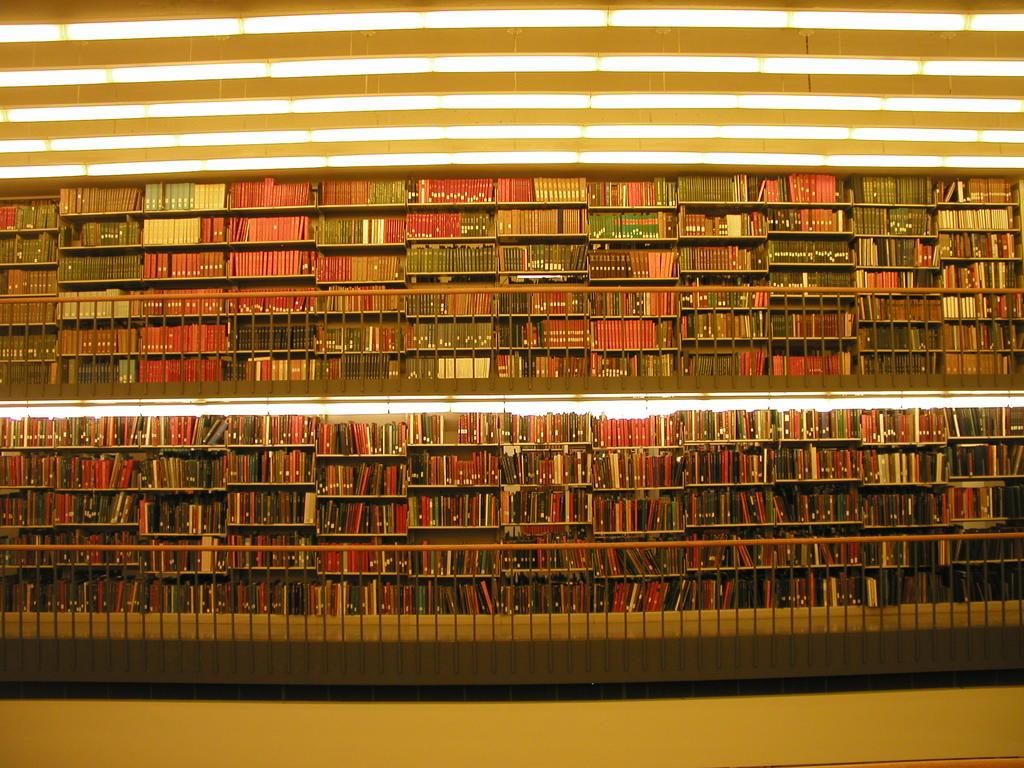What type of furniture is present in the image? There are shelves in the image. What can be found on the shelves? The shelves have books on them. What can be seen providing illumination in the image? There are lights visible in the image. What type of vessel is being used to store the feathers in the image? There is no vessel or feathers present in the image. Who is the partner mentioned in the image? There is no mention of a partner or any relationship in the image. 